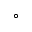<formula> <loc_0><loc_0><loc_500><loc_500>^ { \circ }</formula> 